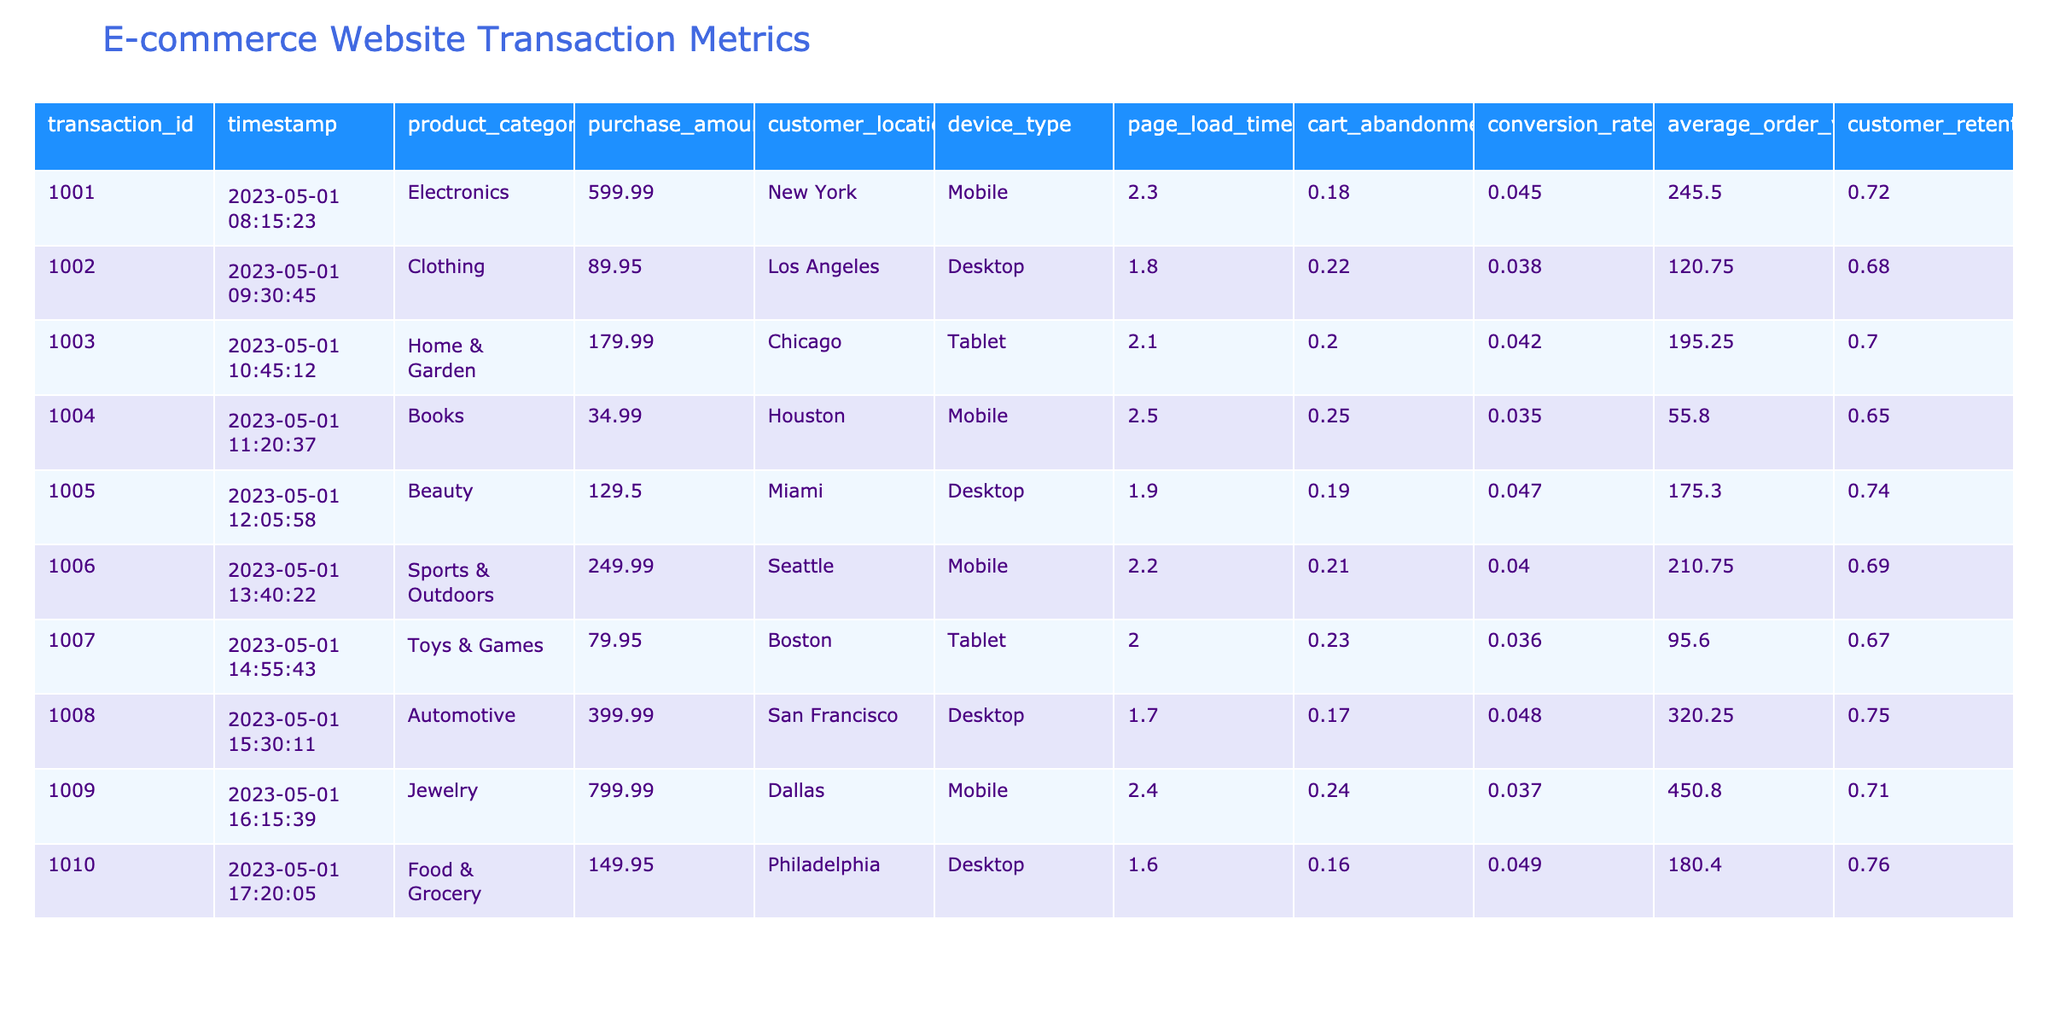What is the purchase amount for the transaction with ID 1004? Looking at the table, we can locate the row corresponding to transaction ID 1004, which shows a purchase amount of 34.99.
Answer: 34.99 What is the average page load time for all transactions? To find the average page load time, sum the page load times: (2.3 + 1.8 + 2.1 + 2.5 + 1.9 + 2.2 + 2.0 + 1.7 + 2.4 + 1.6) = 20.5. There are 10 transactions, so the average is 20.5 / 10 = 2.05.
Answer: 2.05 Which product category had the highest conversion rate? By scanning the conversion rates for each product category, we find that the Electronics category has a conversion rate of 0.045, which is higher than all other categories listed.
Answer: Electronics What is the total purchase amount for transactions made using a mobile device? The transactions made using a mobile device are with IDs 1001, 1004, 1006, 1009. Their respective amounts are 599.99, 34.99, 249.99, and 799.99. Summing these gives us 599.99 + 34.99 + 249.99 + 799.99 = 1684.96.
Answer: 1684.96 Is the cart abandonment rate for the Toys & Games category greater than 0.20? The cart abandonment rate for the Toys & Games category (transaction ID 1007) is 0.23, which is indeed greater than 0.20.
Answer: Yes What is the relationship between average order value and customer retention rate across the transactions? By examining the table, we see that higher average order values often correlate with higher customer retention rates. For instance, the Jewelry category has a high average order value of 450.80 and a retention rate of 0.71, indicating this trend.
Answer: Positive correlation How does the conversion rate compare for products in the Clothes and Beauty categories? The conversion rate for Clothing (0.038) is lower than that for Beauty (0.047), indicating that customers purchasing Beauty products are more likely to complete their transactions than those purchasing Clothing.
Answer: Beauty has a higher conversion rate What is the highest average order value among the transactions listed? By reviewing the average order values in the table, we find that the highest average order value is 450.80 from the Jewelry category.
Answer: 450.80 How many transactions took place from New York, and what is their total purchase amount? There is one transaction from New York (ID 1001), with a purchase amount of 599.99. So, the count is 1 and the total amount is 599.99.
Answer: 1 transaction, 599.99 total Which device type had the best average cart abandonment rate? To determine this, we calculate the average cart abandonment rate for each device type. The averages are: Mobile (0.18 + 0.25 + 0.21 + 0.24) / 4 = 0.225, Desktop (0.22 + 0.19 + 0.16) / 3 = 0.1933, Tablet (0.20 + 0.23) / 2 = 0.215. Desktop has the lowest average, indicating that it had the best performance regarding cart abandonment.
Answer: Desktop 